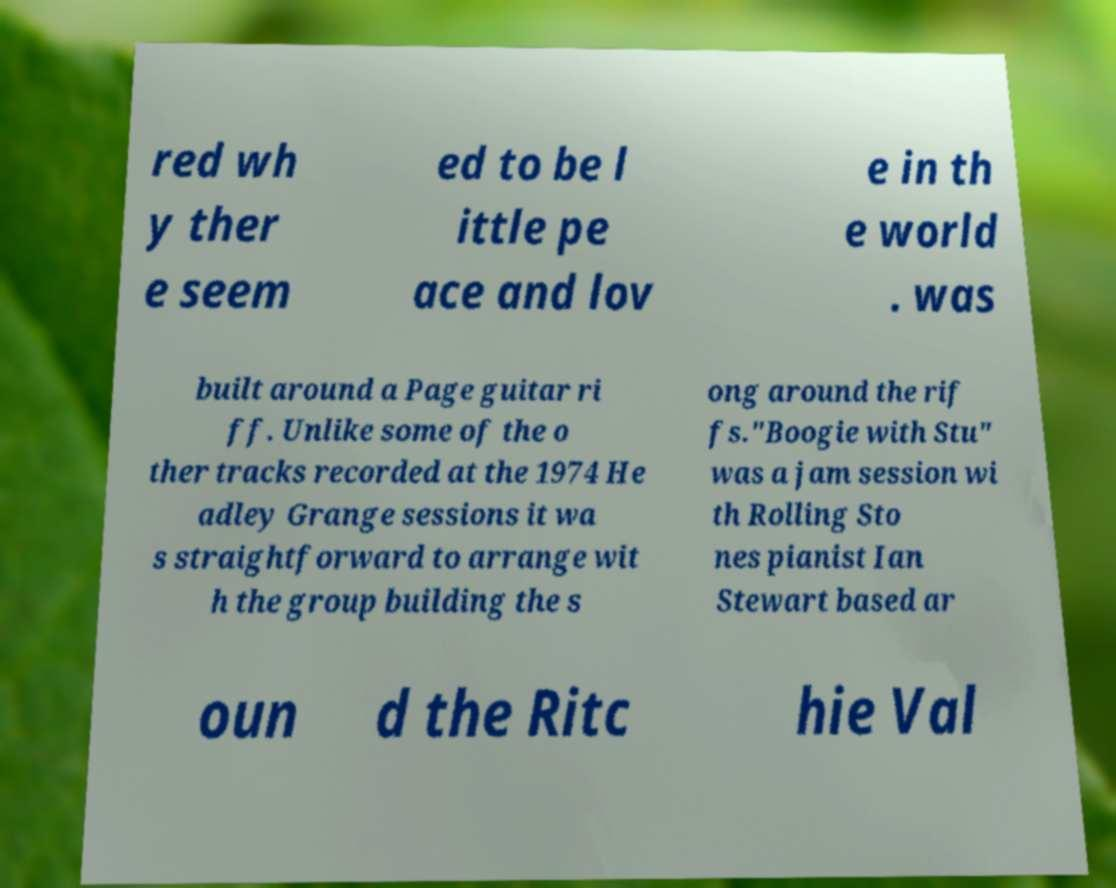For documentation purposes, I need the text within this image transcribed. Could you provide that? red wh y ther e seem ed to be l ittle pe ace and lov e in th e world . was built around a Page guitar ri ff. Unlike some of the o ther tracks recorded at the 1974 He adley Grange sessions it wa s straightforward to arrange wit h the group building the s ong around the rif fs."Boogie with Stu" was a jam session wi th Rolling Sto nes pianist Ian Stewart based ar oun d the Ritc hie Val 